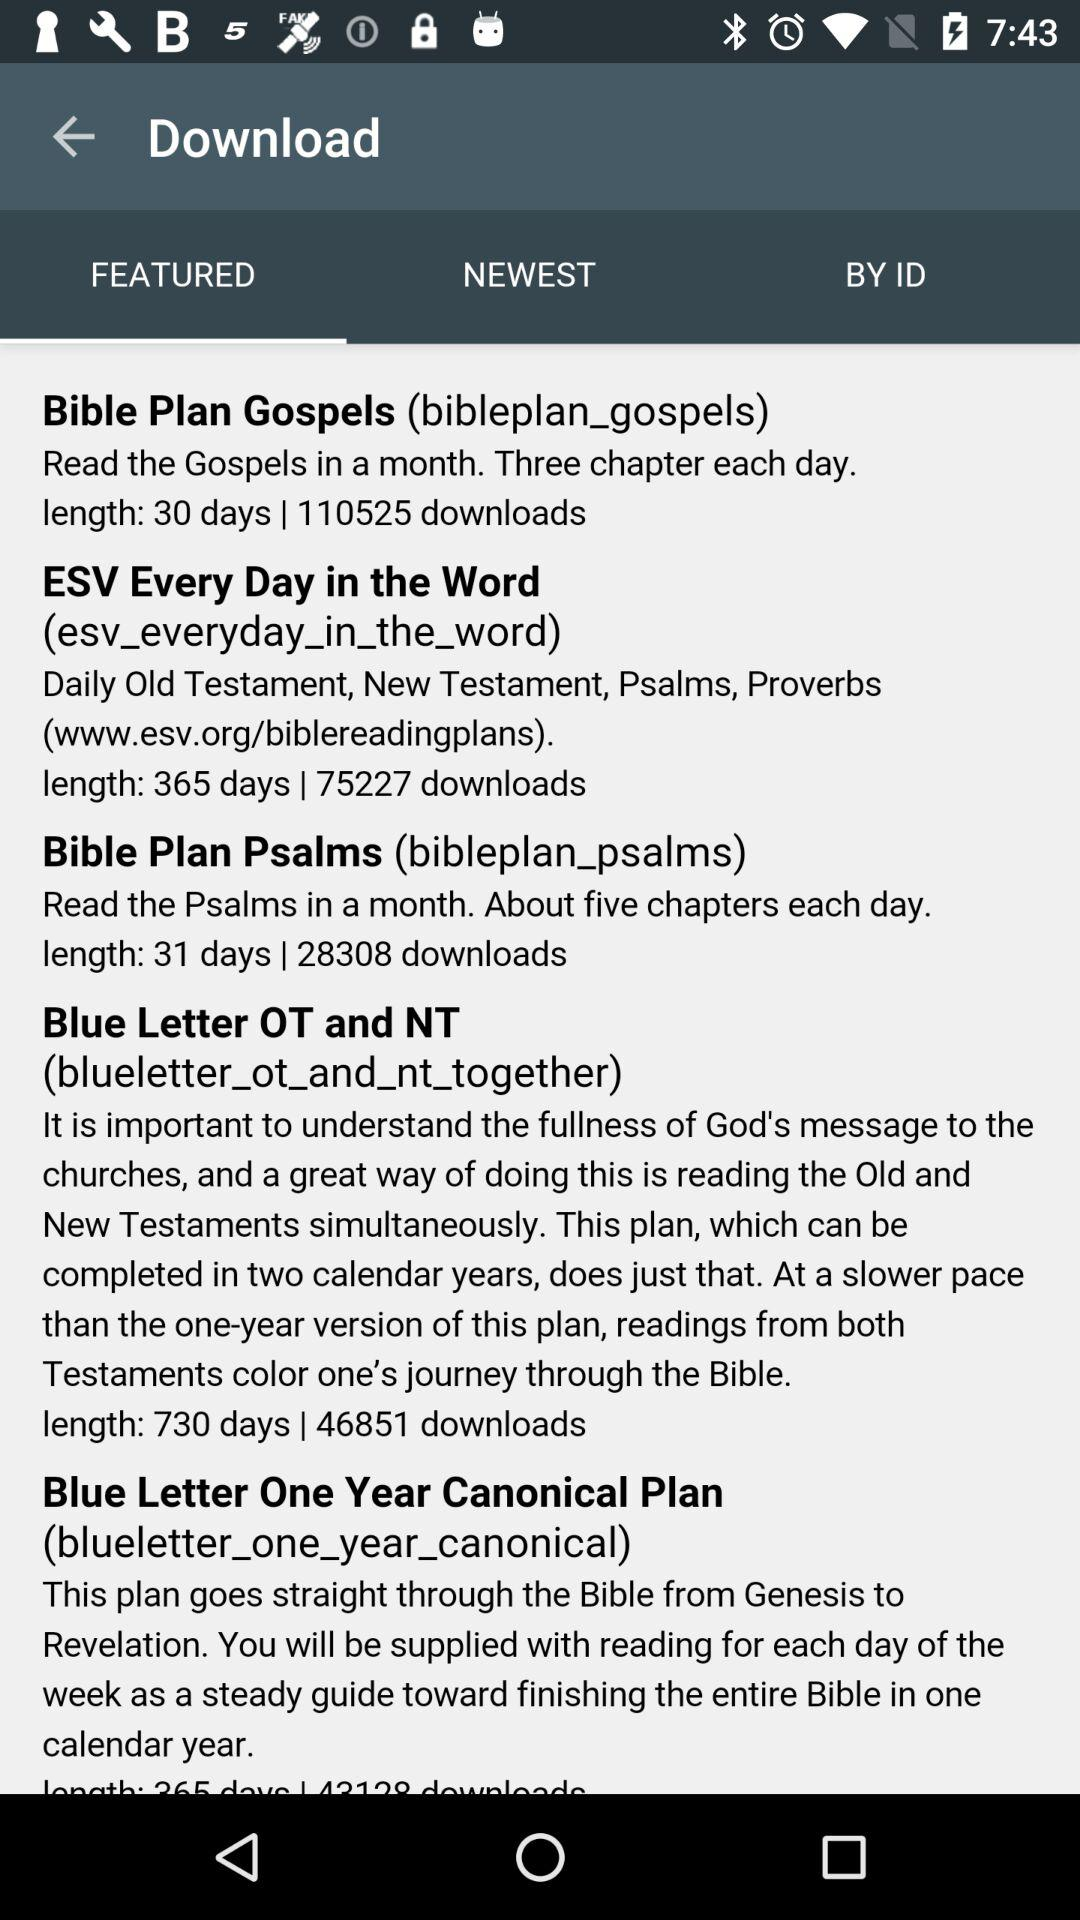How many downloads have there been for the "Bible Plan Psalms"? There are 28308 downloads. 